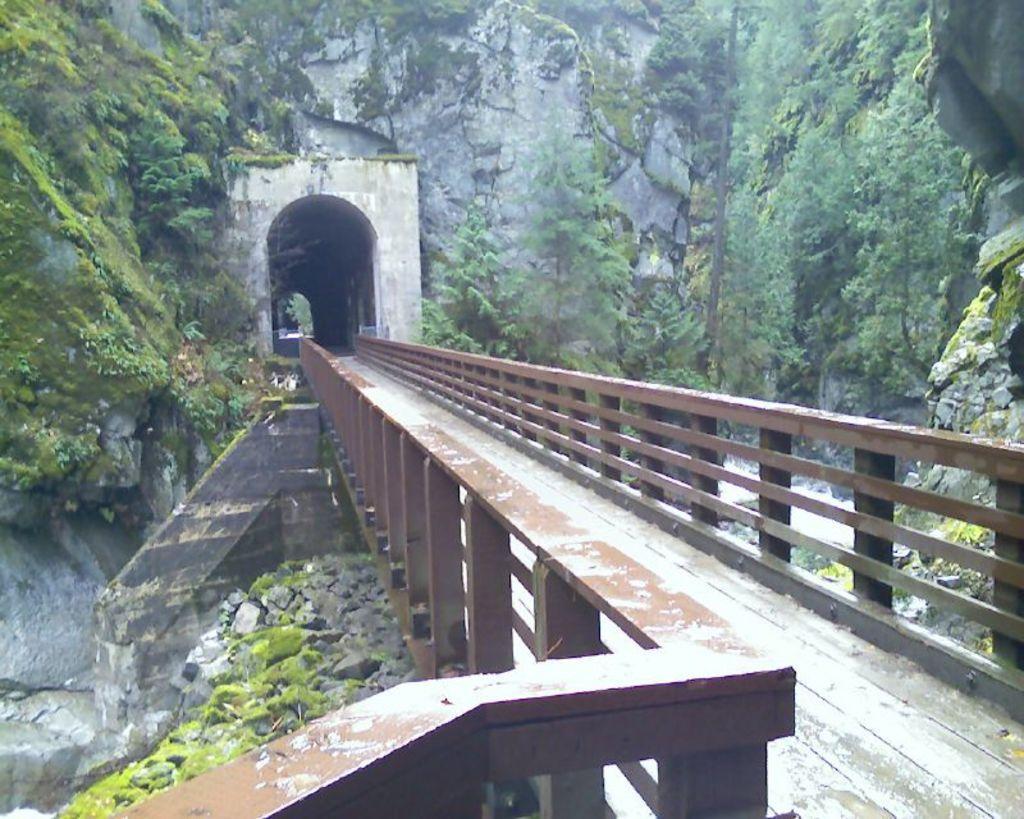Describe this image in one or two sentences. In this image in the foreground there is one bridge, and in the background there is a house and some trees. On the right side there are some rocks and grass. 